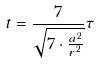Convert formula to latex. <formula><loc_0><loc_0><loc_500><loc_500>t = \frac { 7 } { \sqrt { 7 \cdot \frac { a ^ { 2 } } { r ^ { 2 } } } } \tau</formula> 